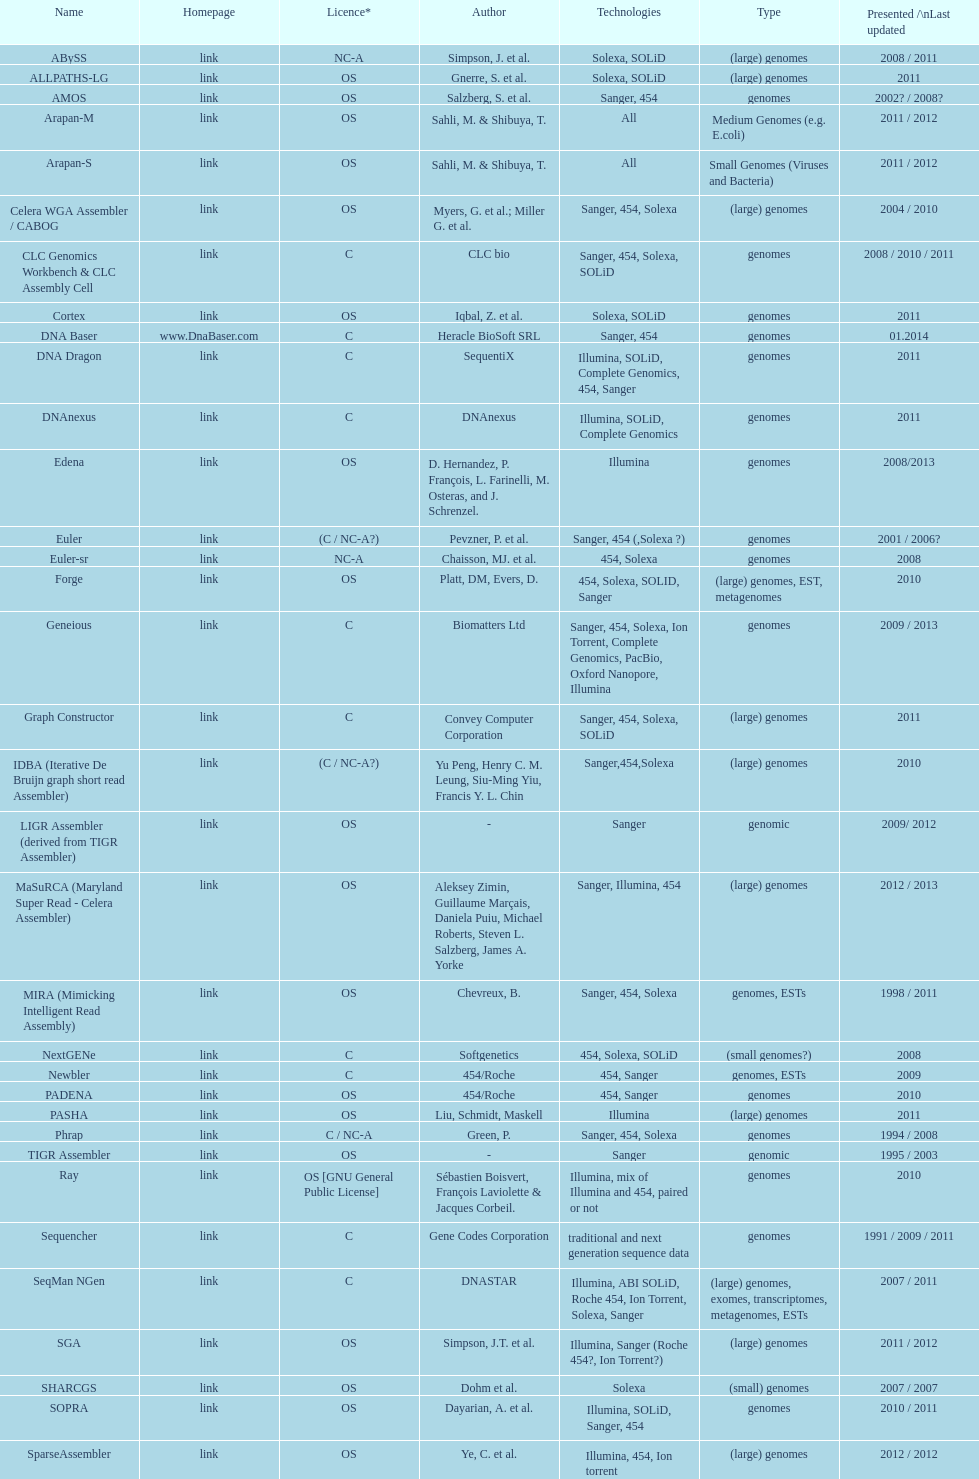When did the velvet receive its latest update? 2009. 